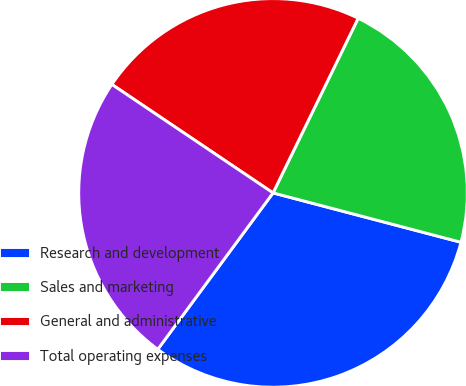Convert chart. <chart><loc_0><loc_0><loc_500><loc_500><pie_chart><fcel>Research and development<fcel>Sales and marketing<fcel>General and administrative<fcel>Total operating expenses<nl><fcel>31.02%<fcel>21.87%<fcel>22.79%<fcel>24.32%<nl></chart> 